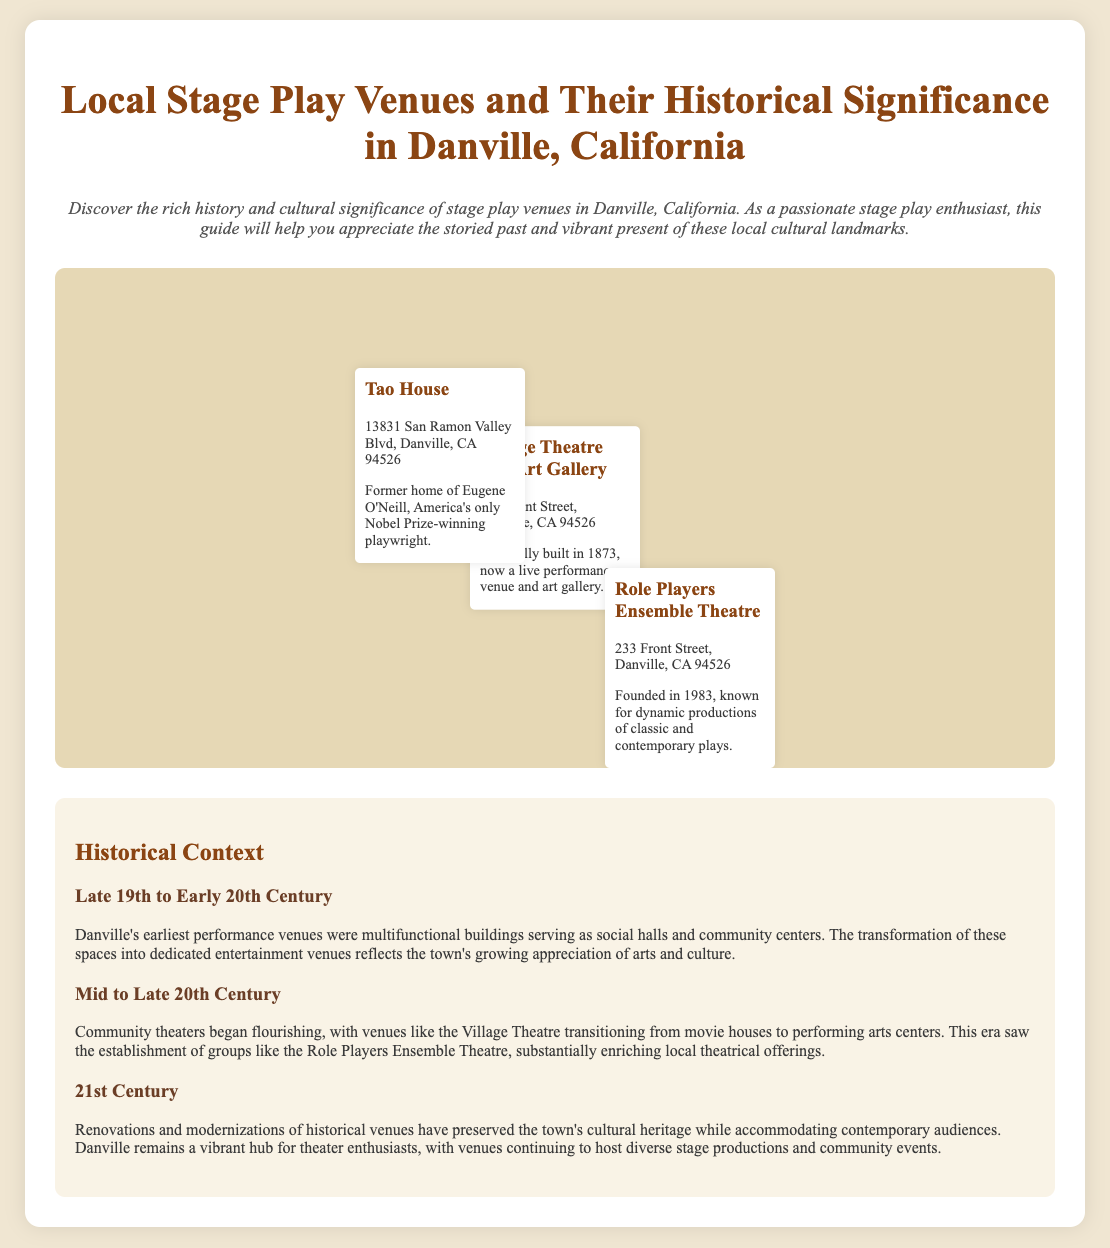what is the address of the Village Theatre and Art Gallery? The address of the Village Theatre and Art Gallery is listed in the document as 233 Front Street, Danville, CA 94526.
Answer: 233 Front Street, Danville, CA 94526 when was the Role Players Ensemble Theatre founded? The document states that the Role Players Ensemble Theatre was founded in 1983.
Answer: 1983 who was the former resident of the Tao House? The document mentions that the Tao House was the former home of Eugene O'Neill.
Answer: Eugene O'Neill which venue was originally built in 1873? The document indicates that the Village Theatre and Art Gallery was originally built in 1873.
Answer: Village Theatre and Art Gallery what type of venue is the Role Players Ensemble Theatre known for? According to the document, the Role Players Ensemble Theatre is known for dynamic productions of classic and contemporary plays.
Answer: dynamic productions of classic and contemporary plays what historical period does the second era in the timeline refer to? The second era in the timeline refers to the Mid to Late 20th Century.
Answer: Mid to Late 20th Century how has Danville preserved its cultural heritage in the 21st Century? The document mentions that renovations and modernizations of historical venues have preserved the town's cultural heritage.
Answer: renovations and modernizations of historical venues what transformation did the Village Theatre undergo? The document states that the Village Theatre transitioned from movie houses to performing arts centers.
Answer: transitioned from movie houses to performing arts centers 